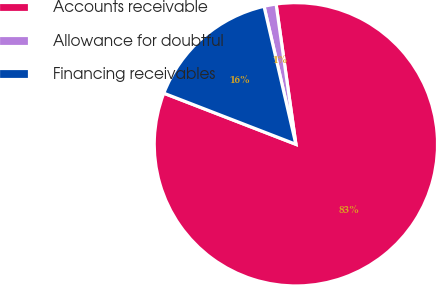Convert chart to OTSL. <chart><loc_0><loc_0><loc_500><loc_500><pie_chart><fcel>Accounts receivable<fcel>Allowance for doubtful<fcel>Financing receivables<nl><fcel>83.11%<fcel>1.38%<fcel>15.51%<nl></chart> 